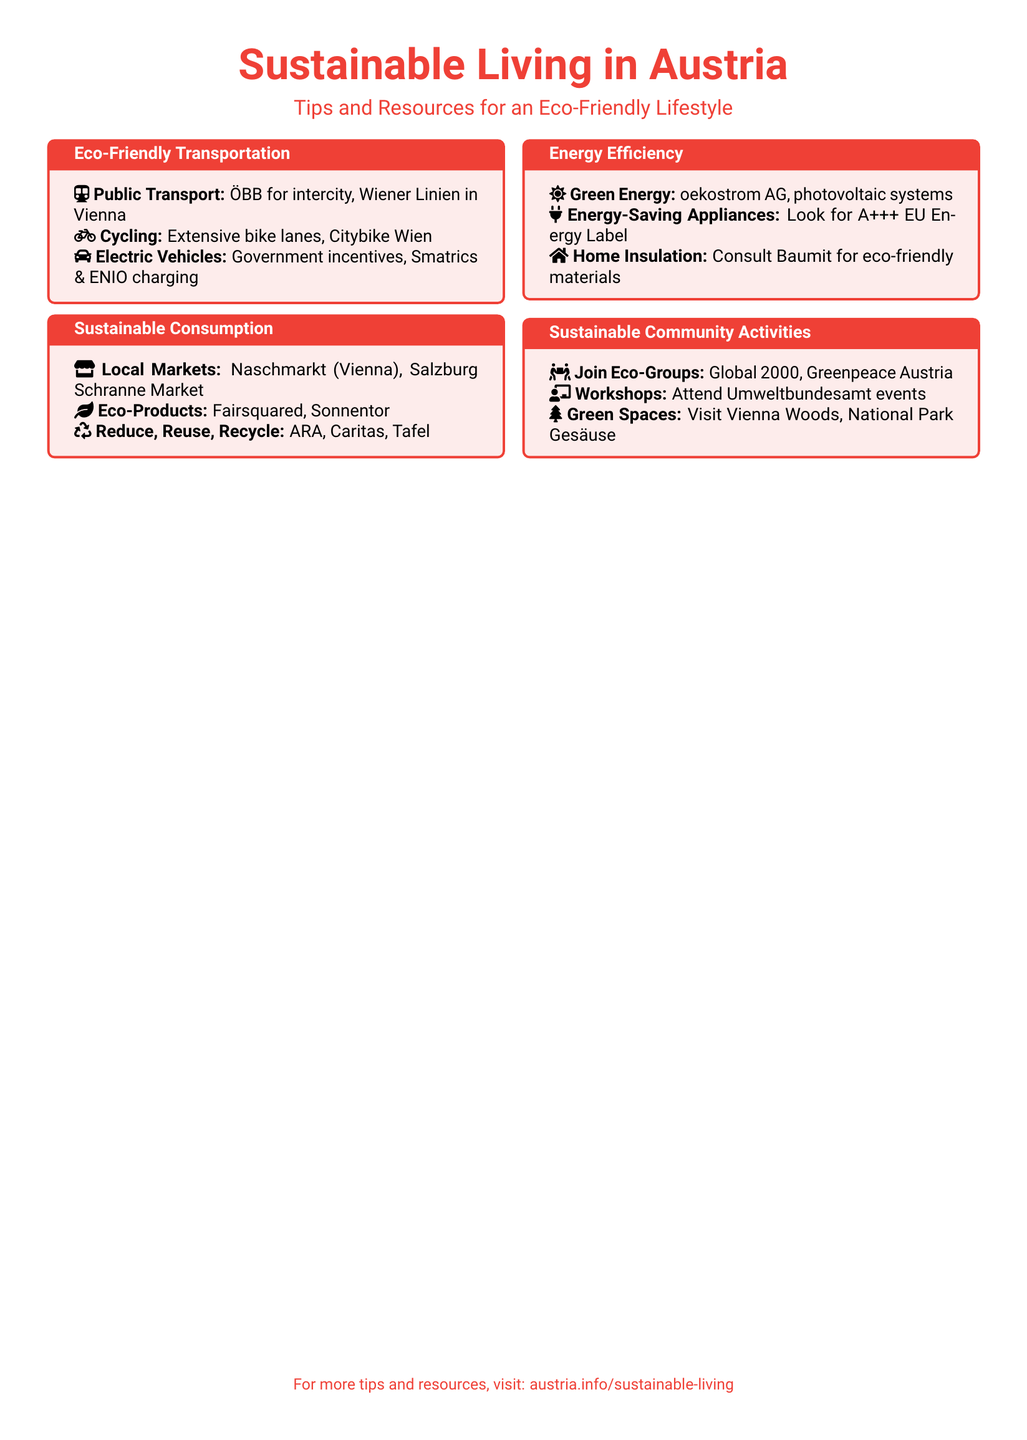What is the title of the document? The title of the document is prominently displayed at the top and reads: "Sustainable Living in Austria."
Answer: Sustainable Living in Austria What is one of the public transport systems mentioned? The document lists ÖBB for intercity travel as a public transport option.
Answer: ÖBB What type of bike sharing service is available in Vienna? The flyer mentions Citybike Wien as a bike-sharing option.
Answer: Citybike Wien Name one eco-friendly product brand mentioned. The document lists Fairsquared as an example of an eco-friendly product brand.
Answer: Fairsquared What organization can you join for eco-activities? The document mentions Global 2000 as an eco-group you can join.
Answer: Global 2000 What type of label should you look for in energy-saving appliances? The document advises looking for the A+++ EU Energy Label.
Answer: A+++ How many tcolorboxes are present in the document? There are four tcolorboxes covering different topics within the document.
Answer: Four What is a recommended green energy provider? The flyer provides oekostrom AG as a green energy provider.
Answer: oekostrom AG What is the email for more tips and resources? The document directs readers to visit austria.info/sustainable-living for more information.
Answer: austria.info/sustainable-living 